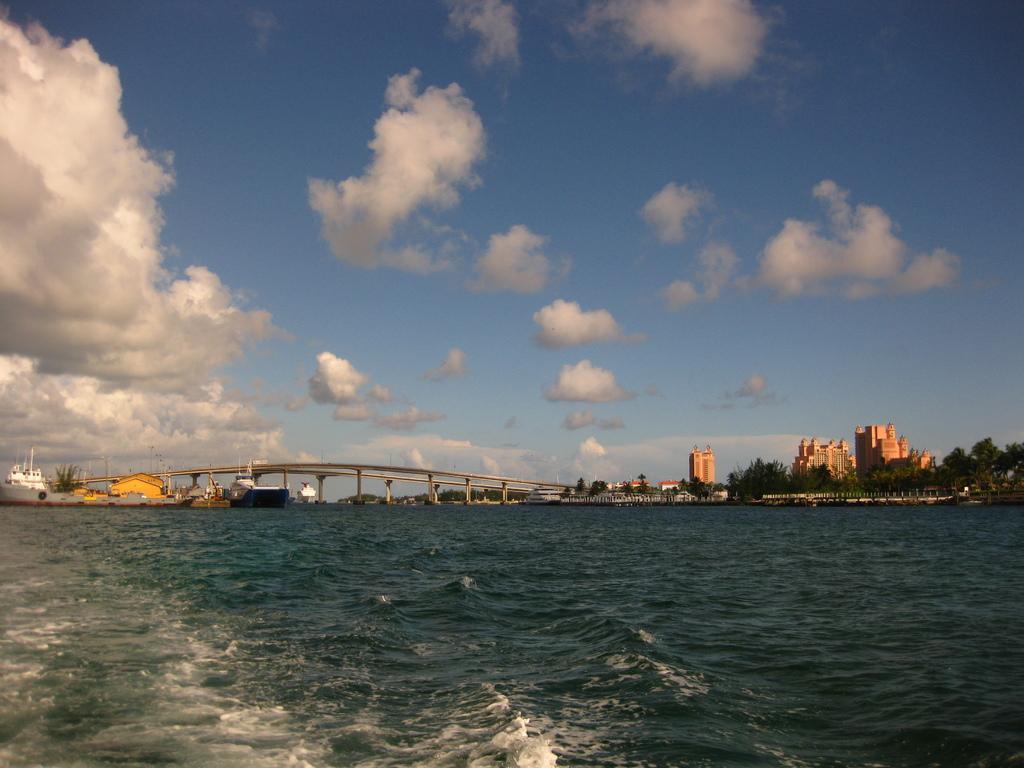How would you summarize this image in a sentence or two? In this picture we can see boats above the water. In the background of the image we can see bridge, trees, buildings and sky with clouds. 